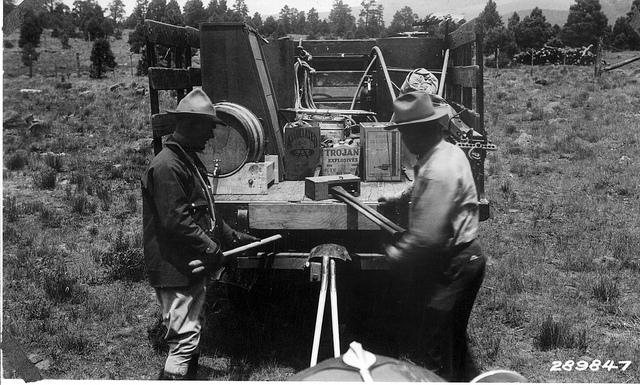Is the man sitting or standing?
Write a very short answer. Standing. Is this a modern day picture?
Write a very short answer. No. What is the man  holding?
Answer briefly. Tools. What is on the truck?
Write a very short answer. Tools. What is taking place with the people?
Keep it brief. They are working. 